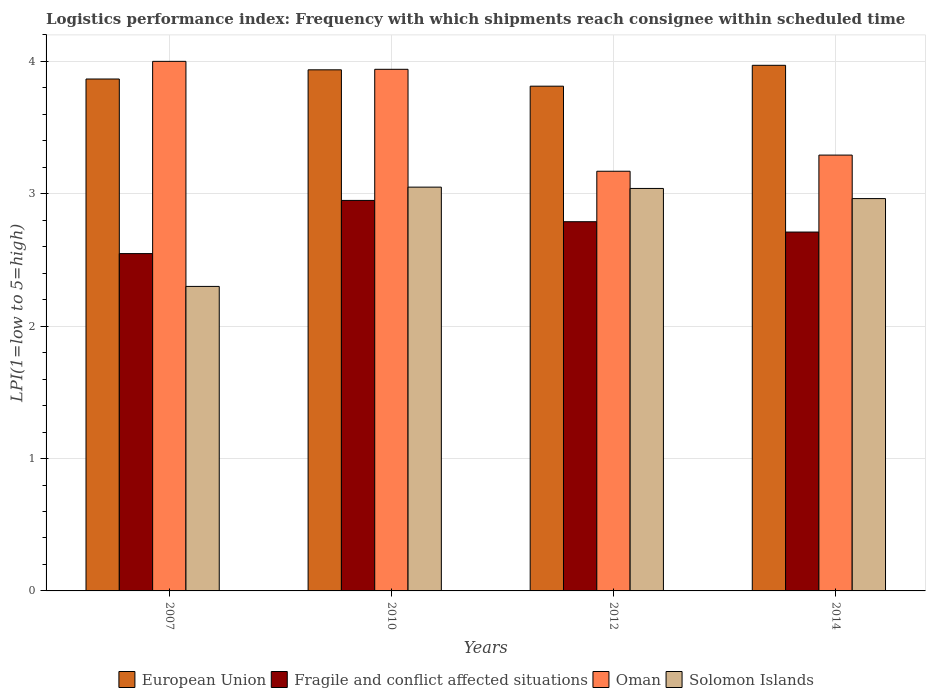How many different coloured bars are there?
Your answer should be compact. 4. Are the number of bars per tick equal to the number of legend labels?
Your answer should be very brief. Yes. What is the label of the 3rd group of bars from the left?
Your answer should be very brief. 2012. What is the logistics performance index in Solomon Islands in 2010?
Ensure brevity in your answer.  3.05. Across all years, what is the maximum logistics performance index in European Union?
Offer a terse response. 3.97. Across all years, what is the minimum logistics performance index in Solomon Islands?
Offer a very short reply. 2.3. In which year was the logistics performance index in Solomon Islands minimum?
Your answer should be very brief. 2007. What is the total logistics performance index in Solomon Islands in the graph?
Offer a terse response. 11.35. What is the difference between the logistics performance index in Solomon Islands in 2010 and that in 2012?
Offer a very short reply. 0.01. What is the difference between the logistics performance index in European Union in 2007 and the logistics performance index in Fragile and conflict affected situations in 2012?
Your answer should be compact. 1.08. What is the average logistics performance index in Oman per year?
Your answer should be very brief. 3.6. In the year 2014, what is the difference between the logistics performance index in Solomon Islands and logistics performance index in European Union?
Give a very brief answer. -1.01. What is the ratio of the logistics performance index in Fragile and conflict affected situations in 2010 to that in 2012?
Offer a very short reply. 1.06. Is the logistics performance index in Fragile and conflict affected situations in 2007 less than that in 2012?
Your answer should be compact. Yes. Is the difference between the logistics performance index in Solomon Islands in 2007 and 2010 greater than the difference between the logistics performance index in European Union in 2007 and 2010?
Your response must be concise. No. What is the difference between the highest and the second highest logistics performance index in European Union?
Your answer should be very brief. 0.03. What is the difference between the highest and the lowest logistics performance index in European Union?
Your answer should be compact. 0.16. In how many years, is the logistics performance index in European Union greater than the average logistics performance index in European Union taken over all years?
Ensure brevity in your answer.  2. Is the sum of the logistics performance index in European Union in 2007 and 2012 greater than the maximum logistics performance index in Fragile and conflict affected situations across all years?
Offer a terse response. Yes. Is it the case that in every year, the sum of the logistics performance index in European Union and logistics performance index in Fragile and conflict affected situations is greater than the sum of logistics performance index in Solomon Islands and logistics performance index in Oman?
Your response must be concise. No. What does the 4th bar from the left in 2007 represents?
Make the answer very short. Solomon Islands. How many bars are there?
Make the answer very short. 16. Are all the bars in the graph horizontal?
Your answer should be compact. No. What is the difference between two consecutive major ticks on the Y-axis?
Your answer should be very brief. 1. How are the legend labels stacked?
Your answer should be compact. Horizontal. What is the title of the graph?
Make the answer very short. Logistics performance index: Frequency with which shipments reach consignee within scheduled time. What is the label or title of the X-axis?
Give a very brief answer. Years. What is the label or title of the Y-axis?
Make the answer very short. LPI(1=low to 5=high). What is the LPI(1=low to 5=high) in European Union in 2007?
Keep it short and to the point. 3.87. What is the LPI(1=low to 5=high) of Fragile and conflict affected situations in 2007?
Ensure brevity in your answer.  2.55. What is the LPI(1=low to 5=high) of Solomon Islands in 2007?
Keep it short and to the point. 2.3. What is the LPI(1=low to 5=high) in European Union in 2010?
Provide a succinct answer. 3.94. What is the LPI(1=low to 5=high) in Fragile and conflict affected situations in 2010?
Your answer should be compact. 2.95. What is the LPI(1=low to 5=high) of Oman in 2010?
Provide a short and direct response. 3.94. What is the LPI(1=low to 5=high) of Solomon Islands in 2010?
Your response must be concise. 3.05. What is the LPI(1=low to 5=high) in European Union in 2012?
Your answer should be compact. 3.81. What is the LPI(1=low to 5=high) of Fragile and conflict affected situations in 2012?
Your answer should be compact. 2.79. What is the LPI(1=low to 5=high) of Oman in 2012?
Offer a very short reply. 3.17. What is the LPI(1=low to 5=high) in Solomon Islands in 2012?
Give a very brief answer. 3.04. What is the LPI(1=low to 5=high) of European Union in 2014?
Ensure brevity in your answer.  3.97. What is the LPI(1=low to 5=high) of Fragile and conflict affected situations in 2014?
Your answer should be compact. 2.71. What is the LPI(1=low to 5=high) of Oman in 2014?
Keep it short and to the point. 3.29. What is the LPI(1=low to 5=high) in Solomon Islands in 2014?
Give a very brief answer. 2.96. Across all years, what is the maximum LPI(1=low to 5=high) of European Union?
Your answer should be compact. 3.97. Across all years, what is the maximum LPI(1=low to 5=high) of Fragile and conflict affected situations?
Make the answer very short. 2.95. Across all years, what is the maximum LPI(1=low to 5=high) in Solomon Islands?
Keep it short and to the point. 3.05. Across all years, what is the minimum LPI(1=low to 5=high) in European Union?
Offer a very short reply. 3.81. Across all years, what is the minimum LPI(1=low to 5=high) in Fragile and conflict affected situations?
Provide a succinct answer. 2.55. Across all years, what is the minimum LPI(1=low to 5=high) in Oman?
Offer a terse response. 3.17. What is the total LPI(1=low to 5=high) in European Union in the graph?
Give a very brief answer. 15.59. What is the total LPI(1=low to 5=high) of Fragile and conflict affected situations in the graph?
Offer a very short reply. 11. What is the total LPI(1=low to 5=high) of Oman in the graph?
Provide a short and direct response. 14.4. What is the total LPI(1=low to 5=high) of Solomon Islands in the graph?
Keep it short and to the point. 11.35. What is the difference between the LPI(1=low to 5=high) in European Union in 2007 and that in 2010?
Your response must be concise. -0.07. What is the difference between the LPI(1=low to 5=high) of Fragile and conflict affected situations in 2007 and that in 2010?
Ensure brevity in your answer.  -0.4. What is the difference between the LPI(1=low to 5=high) in Solomon Islands in 2007 and that in 2010?
Provide a succinct answer. -0.75. What is the difference between the LPI(1=low to 5=high) of European Union in 2007 and that in 2012?
Provide a succinct answer. 0.05. What is the difference between the LPI(1=low to 5=high) of Fragile and conflict affected situations in 2007 and that in 2012?
Offer a very short reply. -0.24. What is the difference between the LPI(1=low to 5=high) of Oman in 2007 and that in 2012?
Give a very brief answer. 0.83. What is the difference between the LPI(1=low to 5=high) of Solomon Islands in 2007 and that in 2012?
Offer a terse response. -0.74. What is the difference between the LPI(1=low to 5=high) of European Union in 2007 and that in 2014?
Your response must be concise. -0.1. What is the difference between the LPI(1=low to 5=high) in Fragile and conflict affected situations in 2007 and that in 2014?
Give a very brief answer. -0.16. What is the difference between the LPI(1=low to 5=high) in Oman in 2007 and that in 2014?
Your response must be concise. 0.71. What is the difference between the LPI(1=low to 5=high) in Solomon Islands in 2007 and that in 2014?
Offer a very short reply. -0.66. What is the difference between the LPI(1=low to 5=high) in European Union in 2010 and that in 2012?
Keep it short and to the point. 0.12. What is the difference between the LPI(1=low to 5=high) in Fragile and conflict affected situations in 2010 and that in 2012?
Provide a succinct answer. 0.16. What is the difference between the LPI(1=low to 5=high) of Oman in 2010 and that in 2012?
Your response must be concise. 0.77. What is the difference between the LPI(1=low to 5=high) of Solomon Islands in 2010 and that in 2012?
Keep it short and to the point. 0.01. What is the difference between the LPI(1=low to 5=high) of European Union in 2010 and that in 2014?
Give a very brief answer. -0.03. What is the difference between the LPI(1=low to 5=high) of Fragile and conflict affected situations in 2010 and that in 2014?
Provide a succinct answer. 0.24. What is the difference between the LPI(1=low to 5=high) of Oman in 2010 and that in 2014?
Keep it short and to the point. 0.65. What is the difference between the LPI(1=low to 5=high) of Solomon Islands in 2010 and that in 2014?
Your answer should be compact. 0.09. What is the difference between the LPI(1=low to 5=high) in European Union in 2012 and that in 2014?
Offer a very short reply. -0.16. What is the difference between the LPI(1=low to 5=high) in Fragile and conflict affected situations in 2012 and that in 2014?
Your response must be concise. 0.08. What is the difference between the LPI(1=low to 5=high) in Oman in 2012 and that in 2014?
Offer a terse response. -0.12. What is the difference between the LPI(1=low to 5=high) of Solomon Islands in 2012 and that in 2014?
Make the answer very short. 0.08. What is the difference between the LPI(1=low to 5=high) of European Union in 2007 and the LPI(1=low to 5=high) of Fragile and conflict affected situations in 2010?
Keep it short and to the point. 0.92. What is the difference between the LPI(1=low to 5=high) of European Union in 2007 and the LPI(1=low to 5=high) of Oman in 2010?
Provide a succinct answer. -0.07. What is the difference between the LPI(1=low to 5=high) in European Union in 2007 and the LPI(1=low to 5=high) in Solomon Islands in 2010?
Make the answer very short. 0.82. What is the difference between the LPI(1=low to 5=high) in Fragile and conflict affected situations in 2007 and the LPI(1=low to 5=high) in Oman in 2010?
Offer a terse response. -1.39. What is the difference between the LPI(1=low to 5=high) in Fragile and conflict affected situations in 2007 and the LPI(1=low to 5=high) in Solomon Islands in 2010?
Make the answer very short. -0.5. What is the difference between the LPI(1=low to 5=high) in European Union in 2007 and the LPI(1=low to 5=high) in Fragile and conflict affected situations in 2012?
Give a very brief answer. 1.08. What is the difference between the LPI(1=low to 5=high) of European Union in 2007 and the LPI(1=low to 5=high) of Oman in 2012?
Give a very brief answer. 0.7. What is the difference between the LPI(1=low to 5=high) of European Union in 2007 and the LPI(1=low to 5=high) of Solomon Islands in 2012?
Your answer should be very brief. 0.83. What is the difference between the LPI(1=low to 5=high) of Fragile and conflict affected situations in 2007 and the LPI(1=low to 5=high) of Oman in 2012?
Your answer should be very brief. -0.62. What is the difference between the LPI(1=low to 5=high) in Fragile and conflict affected situations in 2007 and the LPI(1=low to 5=high) in Solomon Islands in 2012?
Provide a succinct answer. -0.49. What is the difference between the LPI(1=low to 5=high) in European Union in 2007 and the LPI(1=low to 5=high) in Fragile and conflict affected situations in 2014?
Give a very brief answer. 1.16. What is the difference between the LPI(1=low to 5=high) in European Union in 2007 and the LPI(1=low to 5=high) in Oman in 2014?
Your answer should be very brief. 0.57. What is the difference between the LPI(1=low to 5=high) of European Union in 2007 and the LPI(1=low to 5=high) of Solomon Islands in 2014?
Your response must be concise. 0.9. What is the difference between the LPI(1=low to 5=high) in Fragile and conflict affected situations in 2007 and the LPI(1=low to 5=high) in Oman in 2014?
Make the answer very short. -0.74. What is the difference between the LPI(1=low to 5=high) of Fragile and conflict affected situations in 2007 and the LPI(1=low to 5=high) of Solomon Islands in 2014?
Make the answer very short. -0.42. What is the difference between the LPI(1=low to 5=high) in Oman in 2007 and the LPI(1=low to 5=high) in Solomon Islands in 2014?
Your answer should be very brief. 1.04. What is the difference between the LPI(1=low to 5=high) in European Union in 2010 and the LPI(1=low to 5=high) in Fragile and conflict affected situations in 2012?
Offer a terse response. 1.15. What is the difference between the LPI(1=low to 5=high) in European Union in 2010 and the LPI(1=low to 5=high) in Oman in 2012?
Your answer should be compact. 0.77. What is the difference between the LPI(1=low to 5=high) of European Union in 2010 and the LPI(1=low to 5=high) of Solomon Islands in 2012?
Your response must be concise. 0.9. What is the difference between the LPI(1=low to 5=high) of Fragile and conflict affected situations in 2010 and the LPI(1=low to 5=high) of Oman in 2012?
Offer a terse response. -0.22. What is the difference between the LPI(1=low to 5=high) of Fragile and conflict affected situations in 2010 and the LPI(1=low to 5=high) of Solomon Islands in 2012?
Keep it short and to the point. -0.09. What is the difference between the LPI(1=low to 5=high) of Oman in 2010 and the LPI(1=low to 5=high) of Solomon Islands in 2012?
Your answer should be very brief. 0.9. What is the difference between the LPI(1=low to 5=high) of European Union in 2010 and the LPI(1=low to 5=high) of Fragile and conflict affected situations in 2014?
Keep it short and to the point. 1.23. What is the difference between the LPI(1=low to 5=high) in European Union in 2010 and the LPI(1=low to 5=high) in Oman in 2014?
Provide a short and direct response. 0.64. What is the difference between the LPI(1=low to 5=high) of European Union in 2010 and the LPI(1=low to 5=high) of Solomon Islands in 2014?
Provide a succinct answer. 0.97. What is the difference between the LPI(1=low to 5=high) of Fragile and conflict affected situations in 2010 and the LPI(1=low to 5=high) of Oman in 2014?
Ensure brevity in your answer.  -0.34. What is the difference between the LPI(1=low to 5=high) of Fragile and conflict affected situations in 2010 and the LPI(1=low to 5=high) of Solomon Islands in 2014?
Offer a terse response. -0.01. What is the difference between the LPI(1=low to 5=high) in Oman in 2010 and the LPI(1=low to 5=high) in Solomon Islands in 2014?
Your answer should be compact. 0.98. What is the difference between the LPI(1=low to 5=high) in European Union in 2012 and the LPI(1=low to 5=high) in Fragile and conflict affected situations in 2014?
Your answer should be compact. 1.1. What is the difference between the LPI(1=low to 5=high) in European Union in 2012 and the LPI(1=low to 5=high) in Oman in 2014?
Make the answer very short. 0.52. What is the difference between the LPI(1=low to 5=high) in European Union in 2012 and the LPI(1=low to 5=high) in Solomon Islands in 2014?
Ensure brevity in your answer.  0.85. What is the difference between the LPI(1=low to 5=high) of Fragile and conflict affected situations in 2012 and the LPI(1=low to 5=high) of Oman in 2014?
Provide a succinct answer. -0.5. What is the difference between the LPI(1=low to 5=high) of Fragile and conflict affected situations in 2012 and the LPI(1=low to 5=high) of Solomon Islands in 2014?
Ensure brevity in your answer.  -0.17. What is the difference between the LPI(1=low to 5=high) in Oman in 2012 and the LPI(1=low to 5=high) in Solomon Islands in 2014?
Make the answer very short. 0.21. What is the average LPI(1=low to 5=high) in European Union per year?
Keep it short and to the point. 3.9. What is the average LPI(1=low to 5=high) of Fragile and conflict affected situations per year?
Your answer should be compact. 2.75. What is the average LPI(1=low to 5=high) of Oman per year?
Ensure brevity in your answer.  3.6. What is the average LPI(1=low to 5=high) of Solomon Islands per year?
Give a very brief answer. 2.84. In the year 2007, what is the difference between the LPI(1=low to 5=high) in European Union and LPI(1=low to 5=high) in Fragile and conflict affected situations?
Provide a short and direct response. 1.32. In the year 2007, what is the difference between the LPI(1=low to 5=high) in European Union and LPI(1=low to 5=high) in Oman?
Make the answer very short. -0.13. In the year 2007, what is the difference between the LPI(1=low to 5=high) of European Union and LPI(1=low to 5=high) of Solomon Islands?
Give a very brief answer. 1.57. In the year 2007, what is the difference between the LPI(1=low to 5=high) in Fragile and conflict affected situations and LPI(1=low to 5=high) in Oman?
Make the answer very short. -1.45. In the year 2007, what is the difference between the LPI(1=low to 5=high) of Fragile and conflict affected situations and LPI(1=low to 5=high) of Solomon Islands?
Your answer should be very brief. 0.25. In the year 2007, what is the difference between the LPI(1=low to 5=high) of Oman and LPI(1=low to 5=high) of Solomon Islands?
Give a very brief answer. 1.7. In the year 2010, what is the difference between the LPI(1=low to 5=high) of European Union and LPI(1=low to 5=high) of Fragile and conflict affected situations?
Give a very brief answer. 0.99. In the year 2010, what is the difference between the LPI(1=low to 5=high) of European Union and LPI(1=low to 5=high) of Oman?
Your answer should be compact. -0. In the year 2010, what is the difference between the LPI(1=low to 5=high) in European Union and LPI(1=low to 5=high) in Solomon Islands?
Your response must be concise. 0.89. In the year 2010, what is the difference between the LPI(1=low to 5=high) of Fragile and conflict affected situations and LPI(1=low to 5=high) of Oman?
Offer a terse response. -0.99. In the year 2010, what is the difference between the LPI(1=low to 5=high) of Fragile and conflict affected situations and LPI(1=low to 5=high) of Solomon Islands?
Your response must be concise. -0.1. In the year 2010, what is the difference between the LPI(1=low to 5=high) in Oman and LPI(1=low to 5=high) in Solomon Islands?
Keep it short and to the point. 0.89. In the year 2012, what is the difference between the LPI(1=low to 5=high) in European Union and LPI(1=low to 5=high) in Fragile and conflict affected situations?
Provide a short and direct response. 1.02. In the year 2012, what is the difference between the LPI(1=low to 5=high) of European Union and LPI(1=low to 5=high) of Oman?
Offer a terse response. 0.64. In the year 2012, what is the difference between the LPI(1=low to 5=high) in European Union and LPI(1=low to 5=high) in Solomon Islands?
Keep it short and to the point. 0.77. In the year 2012, what is the difference between the LPI(1=low to 5=high) of Fragile and conflict affected situations and LPI(1=low to 5=high) of Oman?
Provide a short and direct response. -0.38. In the year 2012, what is the difference between the LPI(1=low to 5=high) in Fragile and conflict affected situations and LPI(1=low to 5=high) in Solomon Islands?
Your answer should be very brief. -0.25. In the year 2012, what is the difference between the LPI(1=low to 5=high) in Oman and LPI(1=low to 5=high) in Solomon Islands?
Your answer should be compact. 0.13. In the year 2014, what is the difference between the LPI(1=low to 5=high) of European Union and LPI(1=low to 5=high) of Fragile and conflict affected situations?
Your response must be concise. 1.26. In the year 2014, what is the difference between the LPI(1=low to 5=high) in European Union and LPI(1=low to 5=high) in Oman?
Your answer should be very brief. 0.68. In the year 2014, what is the difference between the LPI(1=low to 5=high) in European Union and LPI(1=low to 5=high) in Solomon Islands?
Ensure brevity in your answer.  1.01. In the year 2014, what is the difference between the LPI(1=low to 5=high) in Fragile and conflict affected situations and LPI(1=low to 5=high) in Oman?
Offer a terse response. -0.58. In the year 2014, what is the difference between the LPI(1=low to 5=high) of Fragile and conflict affected situations and LPI(1=low to 5=high) of Solomon Islands?
Provide a succinct answer. -0.25. In the year 2014, what is the difference between the LPI(1=low to 5=high) of Oman and LPI(1=low to 5=high) of Solomon Islands?
Your answer should be very brief. 0.33. What is the ratio of the LPI(1=low to 5=high) of European Union in 2007 to that in 2010?
Give a very brief answer. 0.98. What is the ratio of the LPI(1=low to 5=high) of Fragile and conflict affected situations in 2007 to that in 2010?
Your answer should be compact. 0.86. What is the ratio of the LPI(1=low to 5=high) of Oman in 2007 to that in 2010?
Provide a succinct answer. 1.02. What is the ratio of the LPI(1=low to 5=high) in Solomon Islands in 2007 to that in 2010?
Offer a terse response. 0.75. What is the ratio of the LPI(1=low to 5=high) in European Union in 2007 to that in 2012?
Offer a terse response. 1.01. What is the ratio of the LPI(1=low to 5=high) in Fragile and conflict affected situations in 2007 to that in 2012?
Your answer should be compact. 0.91. What is the ratio of the LPI(1=low to 5=high) of Oman in 2007 to that in 2012?
Your response must be concise. 1.26. What is the ratio of the LPI(1=low to 5=high) in Solomon Islands in 2007 to that in 2012?
Give a very brief answer. 0.76. What is the ratio of the LPI(1=low to 5=high) of European Union in 2007 to that in 2014?
Offer a very short reply. 0.97. What is the ratio of the LPI(1=low to 5=high) of Fragile and conflict affected situations in 2007 to that in 2014?
Offer a very short reply. 0.94. What is the ratio of the LPI(1=low to 5=high) of Oman in 2007 to that in 2014?
Provide a short and direct response. 1.22. What is the ratio of the LPI(1=low to 5=high) in Solomon Islands in 2007 to that in 2014?
Your response must be concise. 0.78. What is the ratio of the LPI(1=low to 5=high) of European Union in 2010 to that in 2012?
Offer a very short reply. 1.03. What is the ratio of the LPI(1=low to 5=high) of Fragile and conflict affected situations in 2010 to that in 2012?
Ensure brevity in your answer.  1.06. What is the ratio of the LPI(1=low to 5=high) of Oman in 2010 to that in 2012?
Your response must be concise. 1.24. What is the ratio of the LPI(1=low to 5=high) of Fragile and conflict affected situations in 2010 to that in 2014?
Offer a very short reply. 1.09. What is the ratio of the LPI(1=low to 5=high) in Oman in 2010 to that in 2014?
Offer a very short reply. 1.2. What is the ratio of the LPI(1=low to 5=high) of Solomon Islands in 2010 to that in 2014?
Your response must be concise. 1.03. What is the ratio of the LPI(1=low to 5=high) of European Union in 2012 to that in 2014?
Keep it short and to the point. 0.96. What is the ratio of the LPI(1=low to 5=high) in Fragile and conflict affected situations in 2012 to that in 2014?
Offer a very short reply. 1.03. What is the ratio of the LPI(1=low to 5=high) of Solomon Islands in 2012 to that in 2014?
Give a very brief answer. 1.03. What is the difference between the highest and the second highest LPI(1=low to 5=high) of European Union?
Offer a very short reply. 0.03. What is the difference between the highest and the second highest LPI(1=low to 5=high) in Fragile and conflict affected situations?
Give a very brief answer. 0.16. What is the difference between the highest and the second highest LPI(1=low to 5=high) of Oman?
Make the answer very short. 0.06. What is the difference between the highest and the lowest LPI(1=low to 5=high) in European Union?
Provide a succinct answer. 0.16. What is the difference between the highest and the lowest LPI(1=low to 5=high) in Fragile and conflict affected situations?
Keep it short and to the point. 0.4. What is the difference between the highest and the lowest LPI(1=low to 5=high) in Oman?
Ensure brevity in your answer.  0.83. 